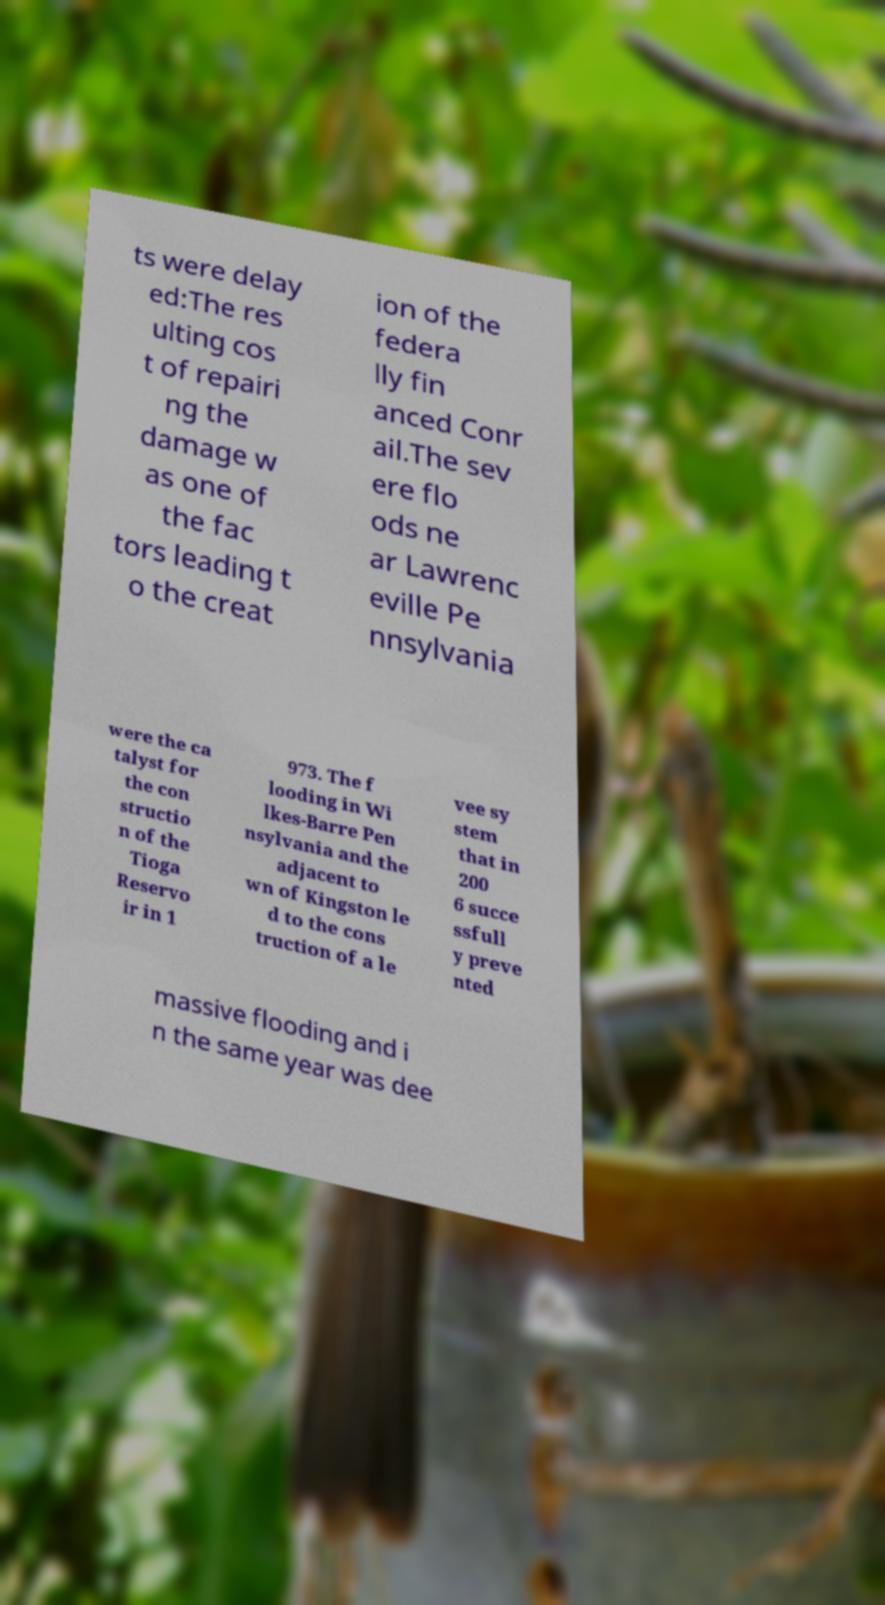What messages or text are displayed in this image? I need them in a readable, typed format. ts were delay ed:The res ulting cos t of repairi ng the damage w as one of the fac tors leading t o the creat ion of the federa lly fin anced Conr ail.The sev ere flo ods ne ar Lawrenc eville Pe nnsylvania were the ca talyst for the con structio n of the Tioga Reservo ir in 1 973. The f looding in Wi lkes-Barre Pen nsylvania and the adjacent to wn of Kingston le d to the cons truction of a le vee sy stem that in 200 6 succe ssfull y preve nted massive flooding and i n the same year was dee 